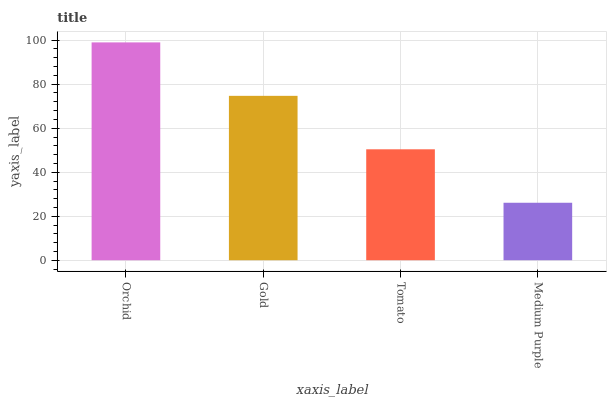Is Medium Purple the minimum?
Answer yes or no. Yes. Is Orchid the maximum?
Answer yes or no. Yes. Is Gold the minimum?
Answer yes or no. No. Is Gold the maximum?
Answer yes or no. No. Is Orchid greater than Gold?
Answer yes or no. Yes. Is Gold less than Orchid?
Answer yes or no. Yes. Is Gold greater than Orchid?
Answer yes or no. No. Is Orchid less than Gold?
Answer yes or no. No. Is Gold the high median?
Answer yes or no. Yes. Is Tomato the low median?
Answer yes or no. Yes. Is Medium Purple the high median?
Answer yes or no. No. Is Medium Purple the low median?
Answer yes or no. No. 